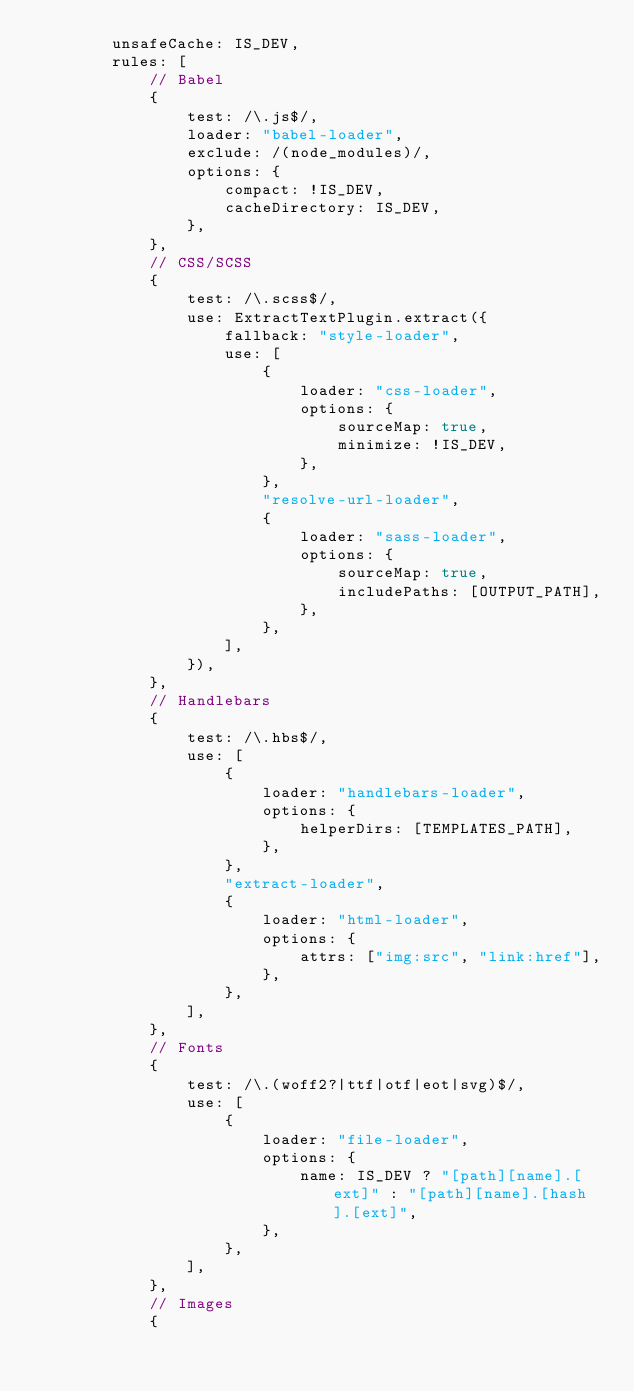Convert code to text. <code><loc_0><loc_0><loc_500><loc_500><_JavaScript_>        unsafeCache: IS_DEV,
        rules: [
            // Babel
            {
                test: /\.js$/,
                loader: "babel-loader",
                exclude: /(node_modules)/,
                options: {
                    compact: !IS_DEV,
                    cacheDirectory: IS_DEV,
                },
            },
            // CSS/SCSS
            {
                test: /\.scss$/,
                use: ExtractTextPlugin.extract({
                    fallback: "style-loader",
                    use: [
                        {
                            loader: "css-loader",
                            options: {
                                sourceMap: true,
                                minimize: !IS_DEV,
                            },
                        },
                        "resolve-url-loader",
                        {
                            loader: "sass-loader",
                            options: {
                                sourceMap: true,
                                includePaths: [OUTPUT_PATH],
                            },
                        },
                    ],
                }),
            },
            // Handlebars
            {
                test: /\.hbs$/,
                use: [
                    {
                        loader: "handlebars-loader",
                        options: {
                            helperDirs: [TEMPLATES_PATH],
                        },
                    },
                    "extract-loader",
                    {
                        loader: "html-loader",
                        options: {
                            attrs: ["img:src", "link:href"],
                        },
                    },
                ],
            },
            // Fonts
            {
                test: /\.(woff2?|ttf|otf|eot|svg)$/,
                use: [
                    {
                        loader: "file-loader",
                        options: {
                            name: IS_DEV ? "[path][name].[ext]" : "[path][name].[hash].[ext]",
                        },
                    },
                ],
            },
            // Images
            {</code> 